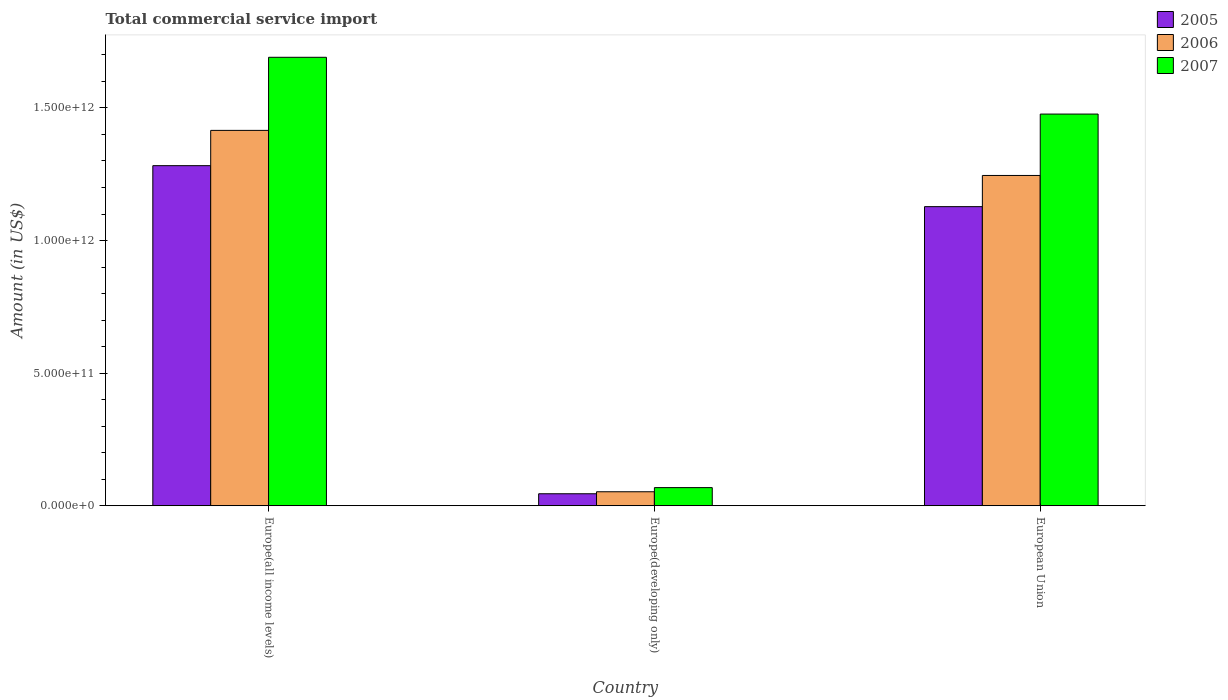How many different coloured bars are there?
Provide a short and direct response. 3. How many groups of bars are there?
Provide a short and direct response. 3. Are the number of bars per tick equal to the number of legend labels?
Make the answer very short. Yes. Are the number of bars on each tick of the X-axis equal?
Offer a very short reply. Yes. How many bars are there on the 2nd tick from the left?
Offer a very short reply. 3. How many bars are there on the 1st tick from the right?
Offer a terse response. 3. What is the label of the 1st group of bars from the left?
Your answer should be compact. Europe(all income levels). In how many cases, is the number of bars for a given country not equal to the number of legend labels?
Give a very brief answer. 0. What is the total commercial service import in 2007 in Europe(all income levels)?
Your answer should be very brief. 1.69e+12. Across all countries, what is the maximum total commercial service import in 2006?
Keep it short and to the point. 1.42e+12. Across all countries, what is the minimum total commercial service import in 2006?
Offer a very short reply. 5.27e+1. In which country was the total commercial service import in 2006 maximum?
Offer a very short reply. Europe(all income levels). In which country was the total commercial service import in 2007 minimum?
Keep it short and to the point. Europe(developing only). What is the total total commercial service import in 2007 in the graph?
Offer a terse response. 3.24e+12. What is the difference between the total commercial service import in 2006 in Europe(developing only) and that in European Union?
Offer a very short reply. -1.19e+12. What is the difference between the total commercial service import in 2005 in Europe(all income levels) and the total commercial service import in 2007 in European Union?
Offer a terse response. -1.95e+11. What is the average total commercial service import in 2007 per country?
Your answer should be compact. 1.08e+12. What is the difference between the total commercial service import of/in 2005 and total commercial service import of/in 2007 in Europe(all income levels)?
Make the answer very short. -4.09e+11. In how many countries, is the total commercial service import in 2006 greater than 1100000000000 US$?
Ensure brevity in your answer.  2. What is the ratio of the total commercial service import in 2007 in Europe(developing only) to that in European Union?
Provide a succinct answer. 0.05. Is the difference between the total commercial service import in 2005 in Europe(all income levels) and Europe(developing only) greater than the difference between the total commercial service import in 2007 in Europe(all income levels) and Europe(developing only)?
Your answer should be compact. No. What is the difference between the highest and the second highest total commercial service import in 2005?
Provide a short and direct response. -1.08e+12. What is the difference between the highest and the lowest total commercial service import in 2005?
Offer a very short reply. 1.24e+12. In how many countries, is the total commercial service import in 2007 greater than the average total commercial service import in 2007 taken over all countries?
Give a very brief answer. 2. What does the 1st bar from the left in Europe(developing only) represents?
Ensure brevity in your answer.  2005. Is it the case that in every country, the sum of the total commercial service import in 2006 and total commercial service import in 2005 is greater than the total commercial service import in 2007?
Offer a very short reply. Yes. How many bars are there?
Keep it short and to the point. 9. Are all the bars in the graph horizontal?
Ensure brevity in your answer.  No. What is the difference between two consecutive major ticks on the Y-axis?
Keep it short and to the point. 5.00e+11. Are the values on the major ticks of Y-axis written in scientific E-notation?
Give a very brief answer. Yes. Does the graph contain grids?
Provide a succinct answer. No. Where does the legend appear in the graph?
Give a very brief answer. Top right. What is the title of the graph?
Ensure brevity in your answer.  Total commercial service import. What is the Amount (in US$) of 2005 in Europe(all income levels)?
Give a very brief answer. 1.28e+12. What is the Amount (in US$) in 2006 in Europe(all income levels)?
Offer a terse response. 1.42e+12. What is the Amount (in US$) of 2007 in Europe(all income levels)?
Provide a short and direct response. 1.69e+12. What is the Amount (in US$) in 2005 in Europe(developing only)?
Provide a short and direct response. 4.51e+1. What is the Amount (in US$) in 2006 in Europe(developing only)?
Make the answer very short. 5.27e+1. What is the Amount (in US$) of 2007 in Europe(developing only)?
Provide a short and direct response. 6.83e+1. What is the Amount (in US$) of 2005 in European Union?
Offer a very short reply. 1.13e+12. What is the Amount (in US$) of 2006 in European Union?
Offer a very short reply. 1.25e+12. What is the Amount (in US$) of 2007 in European Union?
Keep it short and to the point. 1.48e+12. Across all countries, what is the maximum Amount (in US$) in 2005?
Provide a short and direct response. 1.28e+12. Across all countries, what is the maximum Amount (in US$) in 2006?
Offer a very short reply. 1.42e+12. Across all countries, what is the maximum Amount (in US$) of 2007?
Keep it short and to the point. 1.69e+12. Across all countries, what is the minimum Amount (in US$) in 2005?
Your response must be concise. 4.51e+1. Across all countries, what is the minimum Amount (in US$) of 2006?
Keep it short and to the point. 5.27e+1. Across all countries, what is the minimum Amount (in US$) of 2007?
Your answer should be very brief. 6.83e+1. What is the total Amount (in US$) in 2005 in the graph?
Provide a short and direct response. 2.46e+12. What is the total Amount (in US$) of 2006 in the graph?
Your answer should be very brief. 2.71e+12. What is the total Amount (in US$) of 2007 in the graph?
Give a very brief answer. 3.24e+12. What is the difference between the Amount (in US$) of 2005 in Europe(all income levels) and that in Europe(developing only)?
Your answer should be very brief. 1.24e+12. What is the difference between the Amount (in US$) in 2006 in Europe(all income levels) and that in Europe(developing only)?
Your answer should be compact. 1.36e+12. What is the difference between the Amount (in US$) of 2007 in Europe(all income levels) and that in Europe(developing only)?
Give a very brief answer. 1.62e+12. What is the difference between the Amount (in US$) in 2005 in Europe(all income levels) and that in European Union?
Give a very brief answer. 1.55e+11. What is the difference between the Amount (in US$) of 2006 in Europe(all income levels) and that in European Union?
Offer a very short reply. 1.70e+11. What is the difference between the Amount (in US$) of 2007 in Europe(all income levels) and that in European Union?
Ensure brevity in your answer.  2.14e+11. What is the difference between the Amount (in US$) of 2005 in Europe(developing only) and that in European Union?
Make the answer very short. -1.08e+12. What is the difference between the Amount (in US$) in 2006 in Europe(developing only) and that in European Union?
Offer a very short reply. -1.19e+12. What is the difference between the Amount (in US$) in 2007 in Europe(developing only) and that in European Union?
Keep it short and to the point. -1.41e+12. What is the difference between the Amount (in US$) in 2005 in Europe(all income levels) and the Amount (in US$) in 2006 in Europe(developing only)?
Provide a short and direct response. 1.23e+12. What is the difference between the Amount (in US$) of 2005 in Europe(all income levels) and the Amount (in US$) of 2007 in Europe(developing only)?
Offer a very short reply. 1.21e+12. What is the difference between the Amount (in US$) of 2006 in Europe(all income levels) and the Amount (in US$) of 2007 in Europe(developing only)?
Keep it short and to the point. 1.35e+12. What is the difference between the Amount (in US$) of 2005 in Europe(all income levels) and the Amount (in US$) of 2006 in European Union?
Your answer should be compact. 3.69e+1. What is the difference between the Amount (in US$) in 2005 in Europe(all income levels) and the Amount (in US$) in 2007 in European Union?
Your response must be concise. -1.95e+11. What is the difference between the Amount (in US$) in 2006 in Europe(all income levels) and the Amount (in US$) in 2007 in European Union?
Ensure brevity in your answer.  -6.15e+1. What is the difference between the Amount (in US$) in 2005 in Europe(developing only) and the Amount (in US$) in 2006 in European Union?
Offer a terse response. -1.20e+12. What is the difference between the Amount (in US$) of 2005 in Europe(developing only) and the Amount (in US$) of 2007 in European Union?
Provide a short and direct response. -1.43e+12. What is the difference between the Amount (in US$) in 2006 in Europe(developing only) and the Amount (in US$) in 2007 in European Union?
Keep it short and to the point. -1.42e+12. What is the average Amount (in US$) in 2005 per country?
Offer a very short reply. 8.18e+11. What is the average Amount (in US$) of 2006 per country?
Your answer should be compact. 9.04e+11. What is the average Amount (in US$) of 2007 per country?
Offer a very short reply. 1.08e+12. What is the difference between the Amount (in US$) of 2005 and Amount (in US$) of 2006 in Europe(all income levels)?
Your answer should be very brief. -1.33e+11. What is the difference between the Amount (in US$) of 2005 and Amount (in US$) of 2007 in Europe(all income levels)?
Ensure brevity in your answer.  -4.09e+11. What is the difference between the Amount (in US$) in 2006 and Amount (in US$) in 2007 in Europe(all income levels)?
Make the answer very short. -2.76e+11. What is the difference between the Amount (in US$) of 2005 and Amount (in US$) of 2006 in Europe(developing only)?
Give a very brief answer. -7.54e+09. What is the difference between the Amount (in US$) in 2005 and Amount (in US$) in 2007 in Europe(developing only)?
Keep it short and to the point. -2.32e+1. What is the difference between the Amount (in US$) of 2006 and Amount (in US$) of 2007 in Europe(developing only)?
Your response must be concise. -1.56e+1. What is the difference between the Amount (in US$) in 2005 and Amount (in US$) in 2006 in European Union?
Offer a terse response. -1.18e+11. What is the difference between the Amount (in US$) of 2005 and Amount (in US$) of 2007 in European Union?
Provide a short and direct response. -3.49e+11. What is the difference between the Amount (in US$) of 2006 and Amount (in US$) of 2007 in European Union?
Keep it short and to the point. -2.31e+11. What is the ratio of the Amount (in US$) in 2005 in Europe(all income levels) to that in Europe(developing only)?
Offer a terse response. 28.42. What is the ratio of the Amount (in US$) of 2006 in Europe(all income levels) to that in Europe(developing only)?
Offer a very short reply. 26.88. What is the ratio of the Amount (in US$) of 2007 in Europe(all income levels) to that in Europe(developing only)?
Provide a short and direct response. 24.76. What is the ratio of the Amount (in US$) of 2005 in Europe(all income levels) to that in European Union?
Offer a very short reply. 1.14. What is the ratio of the Amount (in US$) of 2006 in Europe(all income levels) to that in European Union?
Provide a short and direct response. 1.14. What is the ratio of the Amount (in US$) in 2007 in Europe(all income levels) to that in European Union?
Your answer should be very brief. 1.14. What is the ratio of the Amount (in US$) in 2005 in Europe(developing only) to that in European Union?
Offer a terse response. 0.04. What is the ratio of the Amount (in US$) of 2006 in Europe(developing only) to that in European Union?
Make the answer very short. 0.04. What is the ratio of the Amount (in US$) of 2007 in Europe(developing only) to that in European Union?
Provide a short and direct response. 0.05. What is the difference between the highest and the second highest Amount (in US$) of 2005?
Offer a very short reply. 1.55e+11. What is the difference between the highest and the second highest Amount (in US$) of 2006?
Provide a succinct answer. 1.70e+11. What is the difference between the highest and the second highest Amount (in US$) in 2007?
Offer a terse response. 2.14e+11. What is the difference between the highest and the lowest Amount (in US$) in 2005?
Ensure brevity in your answer.  1.24e+12. What is the difference between the highest and the lowest Amount (in US$) of 2006?
Your response must be concise. 1.36e+12. What is the difference between the highest and the lowest Amount (in US$) in 2007?
Provide a short and direct response. 1.62e+12. 